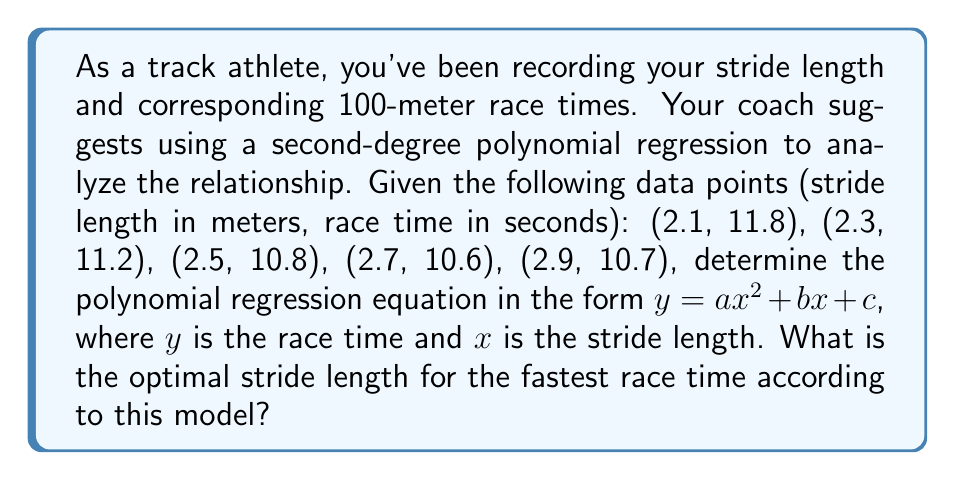Help me with this question. To solve this problem, we'll follow these steps:

1) First, we need to set up the system of equations for the polynomial regression:

   $$\sum y = an\sum x^2 + bn\sum x + cn$$
   $$\sum xy = a\sum x^3 + b\sum x^2 + c\sum x$$
   $$\sum x^2y = a\sum x^4 + b\sum x^3 + c\sum x^2$$

2) Calculate the required sums from the given data:

   $n = 5$
   $\sum x = 12.5$
   $\sum y = 55.1$
   $\sum x^2 = 31.95$
   $\sum x^3 = 82.965$
   $\sum x^4 = 217.5125$
   $\sum xy = 136.31$
   $\sum x^2y = 345.435$

3) Substitute these values into the system of equations:

   $$55.1 = 5a(31.95) + 5b(12.5) + 5c$$
   $$136.31 = a(82.965) + b(31.95) + c(12.5)$$
   $$345.435 = a(217.5125) + b(82.965) + c(31.95)$$

4) Solve this system of equations (using a computer algebra system or matrix methods) to get:

   $a = 1.5357$
   $b = -8.1071$
   $c = 21.5357$

5) Therefore, the polynomial regression equation is:

   $$y = 1.5357x^2 - 8.1071x + 21.5357$$

6) To find the optimal stride length, we need to find the minimum of this function. The minimum occurs where the derivative equals zero:

   $$\frac{dy}{dx} = 3.0714x - 8.1071 = 0$$

7) Solve this equation:

   $$x = \frac{8.1071}{3.0714} = 2.64$$

Therefore, the optimal stride length is approximately 2.64 meters.
Answer: 2.64 meters 